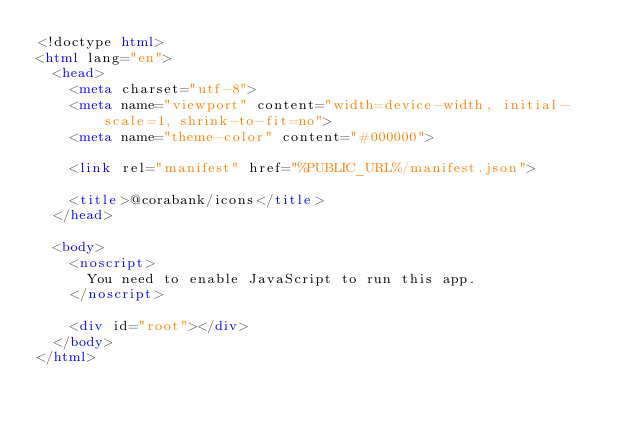<code> <loc_0><loc_0><loc_500><loc_500><_HTML_><!doctype html>
<html lang="en">
  <head>
    <meta charset="utf-8">
    <meta name="viewport" content="width=device-width, initial-scale=1, shrink-to-fit=no">
    <meta name="theme-color" content="#000000">

    <link rel="manifest" href="%PUBLIC_URL%/manifest.json">

    <title>@corabank/icons</title>
  </head>

  <body>
    <noscript>
      You need to enable JavaScript to run this app.
    </noscript>

    <div id="root"></div>
  </body>
</html>
</code> 